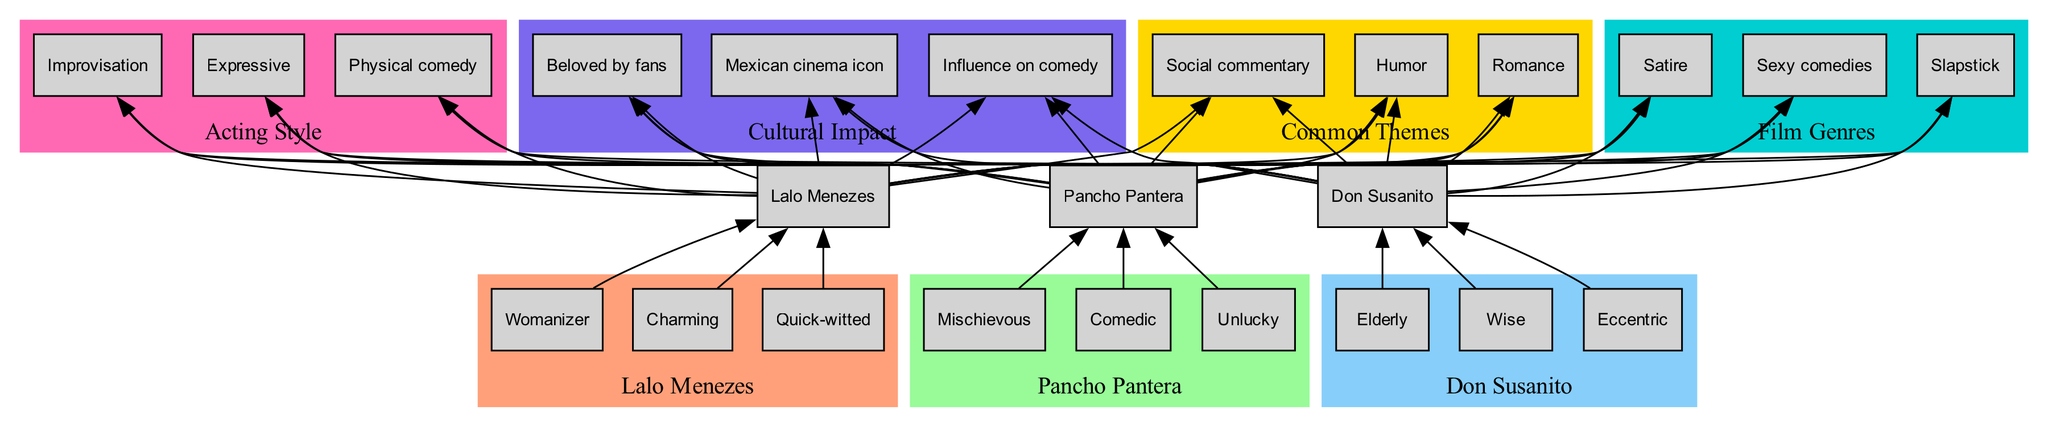What are the traits of Lalo Menezes? The diagram shows a subgraph for Lalo Menezes, listing his traits, which are "Womanizer," "Charming," and "Quick-witted." These traits are directly connected to his character node.
Answer: Womanizer, Charming, Quick-witted How many iconic characters are featured in the diagram? The diagram specifies three iconic characters: Lalo Menezes, Pancho Pantera, and Don Susanito, which can be counted directly from the character nodes in the bottom section.
Answer: 3 Which character is described as eccentric? The traits of Don Susanito include "Elderly," "Wise," and "Eccentric." By identifying the node labeled with Don Susanito and reviewing the traits connected to it, we find "Eccentric."
Answer: Don Susanito What is a common theme depicted in the diagram? The diagram indicates a subgraph labeled "Common Themes," and lists three distinct themes: "Humor," "Romance," and "Social commentary." Any of these themes can be selected as an example from the subgraph.
Answer: Humor Which iconic character has traits related to mischief? In examining the traits connected to Pancho Pantera, we see "Mischievous," "Comedic," and "Unlucky." Since “Mischievous” is the trait denoting mischief, we can conclude it relates to Pancho Pantera.
Answer: Pancho Pantera How many edges connect the character Don Susanito to themes? Each iconic character connects to the common themes through edges, and since there are three themes listed, Don Susanito has three edges connecting it to those themes.
Answer: 3 Which acting style is highlighted in the diagram? The acting styles are shown in a subgraph labeled "Acting Style," which includes "Expressive," "Physical comedy," and "Improvisation." We can refer to any of these styles to answer the question.
Answer: Expressive What color represents the "Film Genres" node? The subgraph for "Film Genres" is illustrated in the diagram with a specific color identified by its attributes, which is teal (#00CED1). This color is distinctively displayed in the diagram.
Answer: Teal Which two characters share the theme of "Romance"? In the diagram, both Lalo Menezes and Don Susanito have edges leading to the theme "Romance." By identifying the connections from each character node to the themes, we see they both connect to this particular theme.
Answer: Lalo Menezes, Don Susanito 